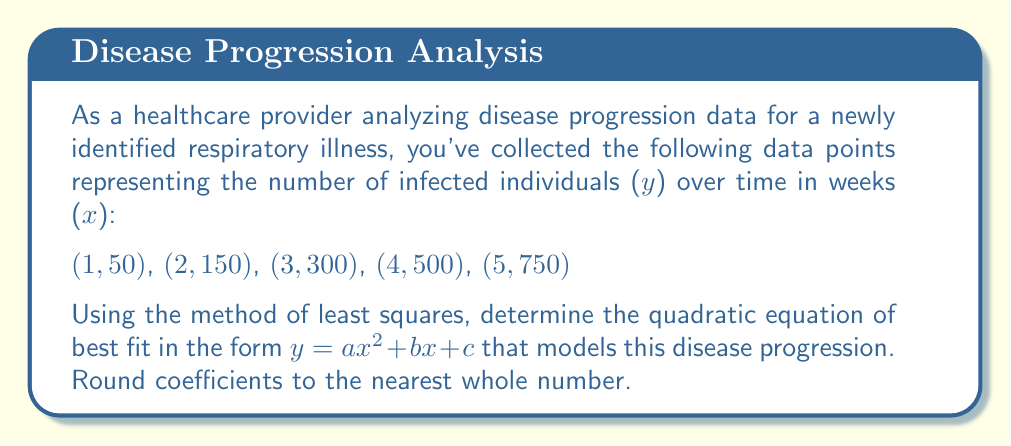Solve this math problem. To find the quadratic equation of best fit using the method of least squares, we need to solve a system of equations. Let's follow these steps:

1) For a quadratic equation $y = ax^2 + bx + c$, we need to solve:

   $$\begin{cases}
   \sum y = an\sum x^2 + b\sum x + nc \\
   \sum xy = a\sum x^3 + b\sum x^2 + c\sum x \\
   \sum x^2y = a\sum x^4 + b\sum x^3 + c\sum x^2
   \end{cases}$$

2) First, let's calculate the necessary sums:

   $\sum x = 1 + 2 + 3 + 4 + 5 = 15$
   $\sum y = 50 + 150 + 300 + 500 + 750 = 1750$
   $\sum x^2 = 1 + 4 + 9 + 16 + 25 = 55$
   $\sum x^3 = 1 + 8 + 27 + 64 + 125 = 225$
   $\sum x^4 = 1 + 16 + 81 + 256 + 625 = 979$
   $\sum xy = 50 + 300 + 900 + 2000 + 3750 = 7000$
   $\sum x^2y = 50 + 600 + 2700 + 8000 + 18750 = 30100$

3) Now we can set up our system of equations:

   $$\begin{cases}
   1750 = 55a + 15b + 5c \\
   7000 = 225a + 55b + 15c \\
   30100 = 979a + 225b + 55c
   \end{cases}$$

4) Solving this system of equations (using matrix methods or elimination) gives us:

   $a \approx 21.4$
   $b \approx 18.6$
   $c \approx 10.0$

5) Rounding to the nearest whole number:

   $a = 21$
   $b = 19$
   $c = 10$

Therefore, the quadratic equation of best fit is $y = 21x^2 + 19x + 10$.
Answer: $y = 21x^2 + 19x + 10$ 